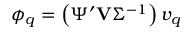Convert formula to latex. <formula><loc_0><loc_0><loc_500><loc_500>\phi _ { q } = \left ( \Psi ^ { \prime } V \Sigma ^ { - 1 } \right ) v _ { q }</formula> 